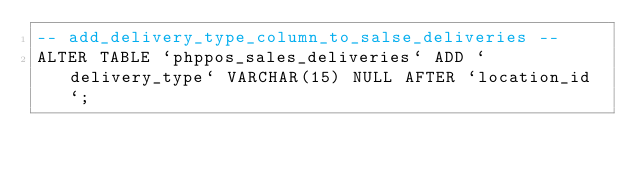<code> <loc_0><loc_0><loc_500><loc_500><_SQL_>-- add_delivery_type_column_to_salse_deliveries --
ALTER TABLE `phppos_sales_deliveries` ADD `delivery_type` VARCHAR(15) NULL AFTER `location_id`;</code> 